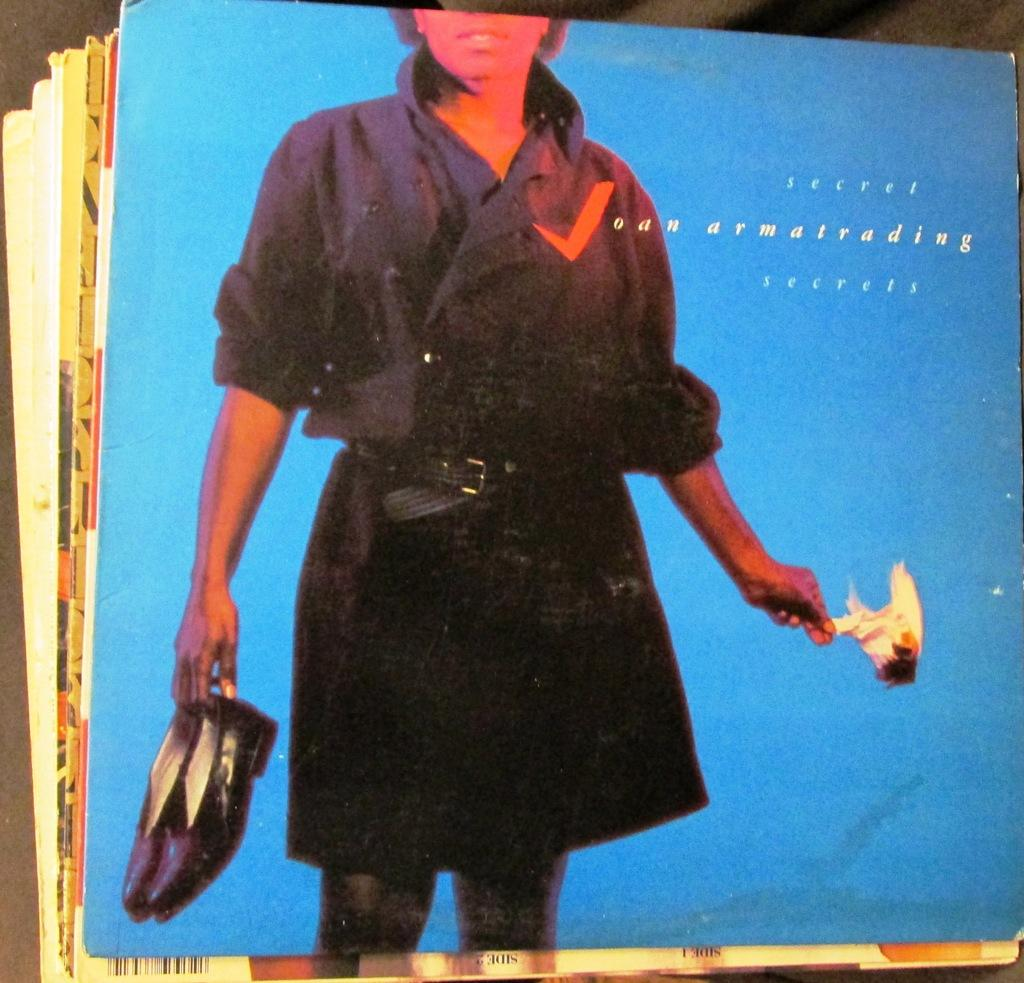What objects are present in the image? There are cards in the image. What is depicted on the cards? The cards have a picture of a person printed on them. Are there any words on the cards? Yes, there is text on the cards. How many sheep are visible on the cards in the image? There are no sheep present on the cards in the image. What is the tax rate for the value of the cards in the image? There is no information about tax rates or values for the cards in the image. 